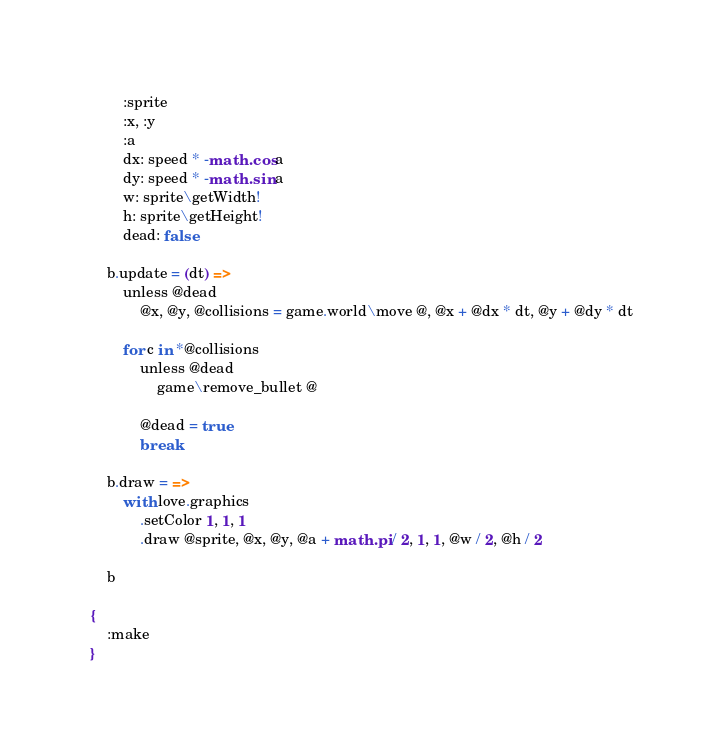Convert code to text. <code><loc_0><loc_0><loc_500><loc_500><_MoonScript_>        :sprite
        :x, :y
        :a
        dx: speed * -math.cos a
        dy: speed * -math.sin a
        w: sprite\getWidth!
        h: sprite\getHeight!
        dead: false

    b.update = (dt) =>
        unless @dead
            @x, @y, @collisions = game.world\move @, @x + @dx * dt, @y + @dy * dt

        for c in *@collisions
            unless @dead
                game\remove_bullet @

            @dead = true
            break

    b.draw = =>
        with love.graphics
            .setColor 1, 1, 1
            .draw @sprite, @x, @y, @a + math.pi / 2, 1, 1, @w / 2, @h / 2

    b

{
    :make
}</code> 